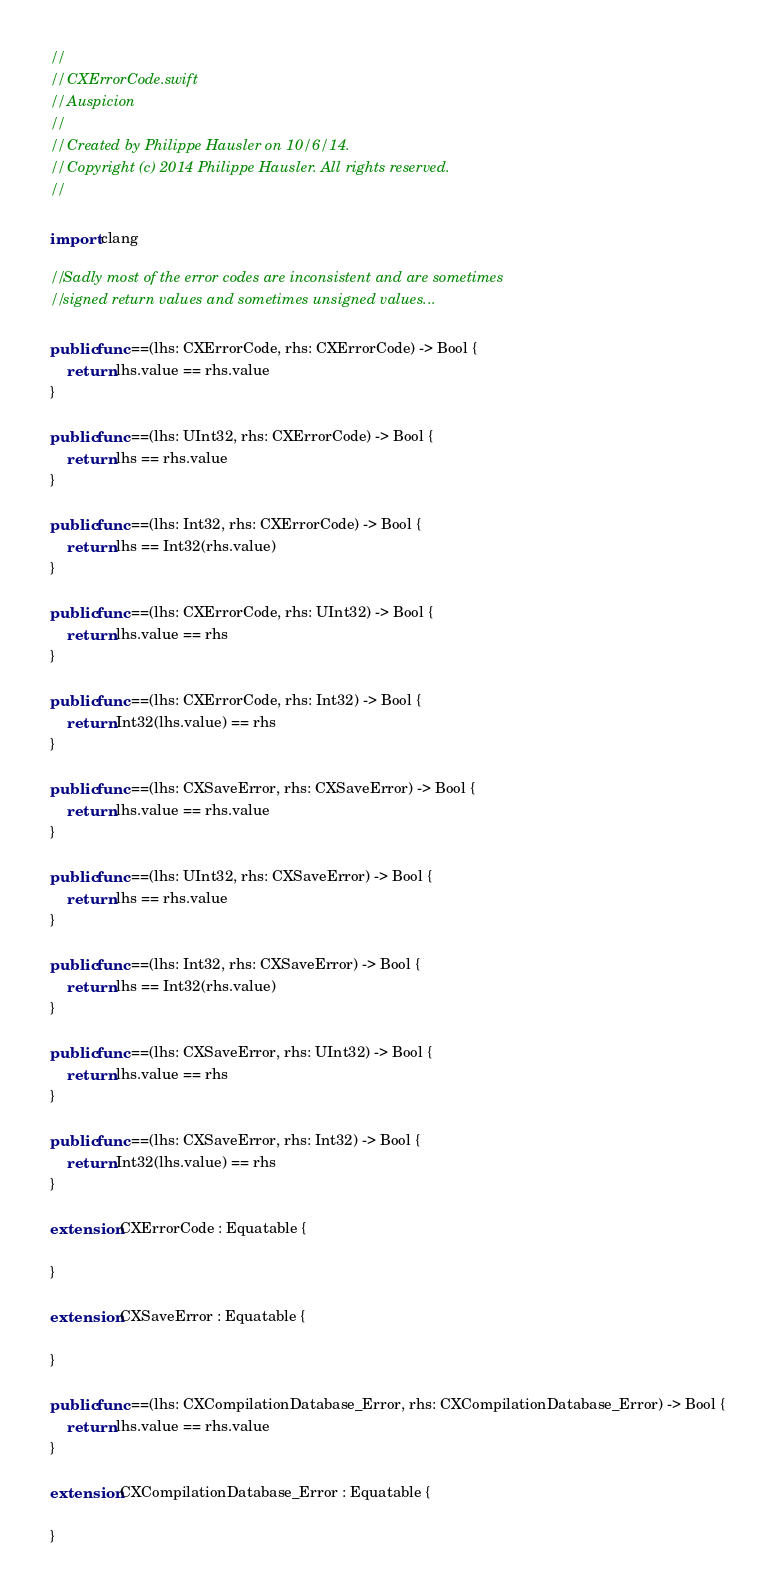<code> <loc_0><loc_0><loc_500><loc_500><_Swift_>//
//  CXErrorCode.swift
//  Auspicion
//
//  Created by Philippe Hausler on 10/6/14.
//  Copyright (c) 2014 Philippe Hausler. All rights reserved.
//

import clang

// Sadly most of the error codes are inconsistent and are sometimes 
// signed return values and sometimes unsigned values...

public func ==(lhs: CXErrorCode, rhs: CXErrorCode) -> Bool {
    return lhs.value == rhs.value
}

public func ==(lhs: UInt32, rhs: CXErrorCode) -> Bool {
    return lhs == rhs.value
}

public func ==(lhs: Int32, rhs: CXErrorCode) -> Bool {
    return lhs == Int32(rhs.value)
}

public func ==(lhs: CXErrorCode, rhs: UInt32) -> Bool {
    return lhs.value == rhs
}

public func ==(lhs: CXErrorCode, rhs: Int32) -> Bool {
    return Int32(lhs.value) == rhs
}

public func ==(lhs: CXSaveError, rhs: CXSaveError) -> Bool {
    return lhs.value == rhs.value
}

public func ==(lhs: UInt32, rhs: CXSaveError) -> Bool {
    return lhs == rhs.value
}

public func ==(lhs: Int32, rhs: CXSaveError) -> Bool {
    return lhs == Int32(rhs.value)
}

public func ==(lhs: CXSaveError, rhs: UInt32) -> Bool {
    return lhs.value == rhs
}

public func ==(lhs: CXSaveError, rhs: Int32) -> Bool {
    return Int32(lhs.value) == rhs
}

extension CXErrorCode : Equatable {
    
}

extension CXSaveError : Equatable {
    
}

public func ==(lhs: CXCompilationDatabase_Error, rhs: CXCompilationDatabase_Error) -> Bool {
    return lhs.value == rhs.value
}

extension CXCompilationDatabase_Error : Equatable {
    
}</code> 